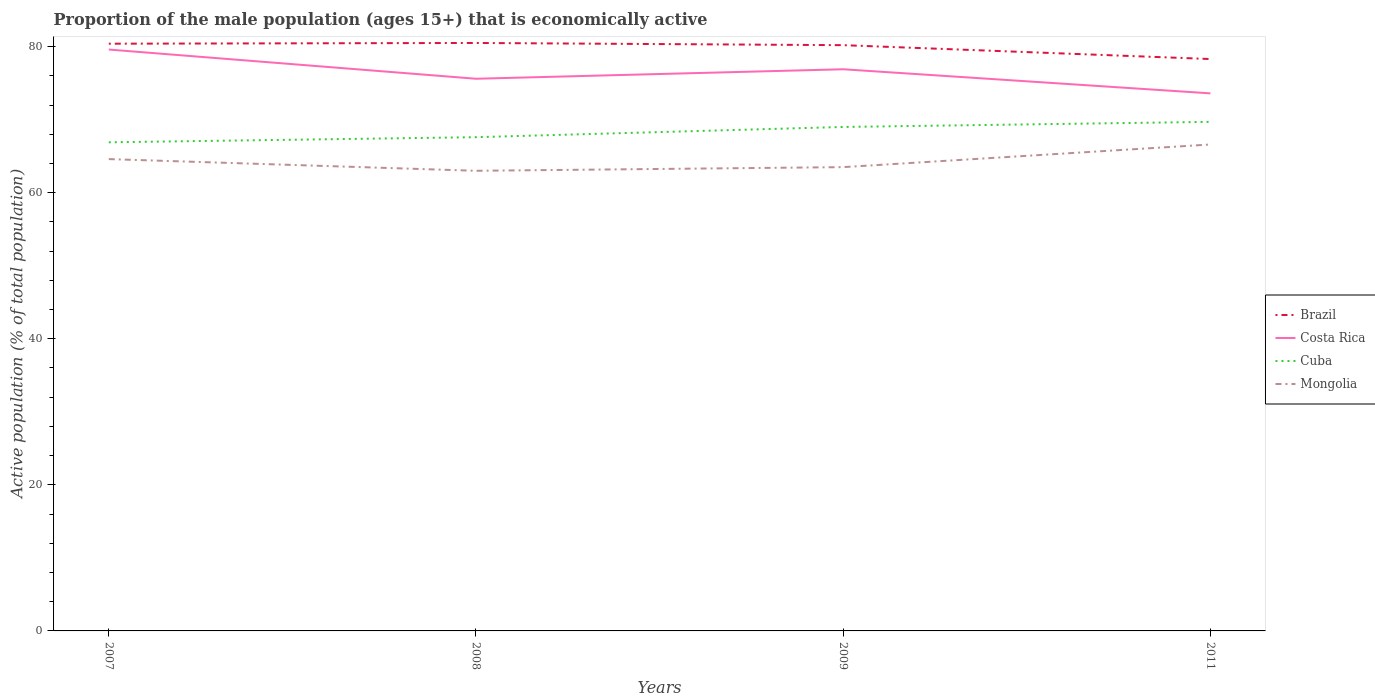Does the line corresponding to Brazil intersect with the line corresponding to Cuba?
Your answer should be very brief. No. Is the number of lines equal to the number of legend labels?
Provide a succinct answer. Yes. Across all years, what is the maximum proportion of the male population that is economically active in Brazil?
Offer a terse response. 78.3. In which year was the proportion of the male population that is economically active in Costa Rica maximum?
Keep it short and to the point. 2011. What is the total proportion of the male population that is economically active in Mongolia in the graph?
Provide a short and direct response. 1.1. What is the difference between the highest and the second highest proportion of the male population that is economically active in Brazil?
Keep it short and to the point. 2.2. What is the difference between the highest and the lowest proportion of the male population that is economically active in Cuba?
Give a very brief answer. 2. Are the values on the major ticks of Y-axis written in scientific E-notation?
Ensure brevity in your answer.  No. How many legend labels are there?
Provide a succinct answer. 4. How are the legend labels stacked?
Make the answer very short. Vertical. What is the title of the graph?
Your answer should be very brief. Proportion of the male population (ages 15+) that is economically active. Does "Luxembourg" appear as one of the legend labels in the graph?
Give a very brief answer. No. What is the label or title of the X-axis?
Your answer should be very brief. Years. What is the label or title of the Y-axis?
Offer a terse response. Active population (% of total population). What is the Active population (% of total population) of Brazil in 2007?
Give a very brief answer. 80.4. What is the Active population (% of total population) in Costa Rica in 2007?
Provide a short and direct response. 79.6. What is the Active population (% of total population) of Cuba in 2007?
Your answer should be compact. 66.9. What is the Active population (% of total population) of Mongolia in 2007?
Keep it short and to the point. 64.6. What is the Active population (% of total population) in Brazil in 2008?
Offer a terse response. 80.5. What is the Active population (% of total population) in Costa Rica in 2008?
Provide a short and direct response. 75.6. What is the Active population (% of total population) of Cuba in 2008?
Your response must be concise. 67.6. What is the Active population (% of total population) of Brazil in 2009?
Provide a succinct answer. 80.2. What is the Active population (% of total population) of Costa Rica in 2009?
Provide a succinct answer. 76.9. What is the Active population (% of total population) of Cuba in 2009?
Provide a short and direct response. 69. What is the Active population (% of total population) in Mongolia in 2009?
Offer a very short reply. 63.5. What is the Active population (% of total population) of Brazil in 2011?
Offer a very short reply. 78.3. What is the Active population (% of total population) of Costa Rica in 2011?
Make the answer very short. 73.6. What is the Active population (% of total population) of Cuba in 2011?
Offer a terse response. 69.7. What is the Active population (% of total population) in Mongolia in 2011?
Ensure brevity in your answer.  66.6. Across all years, what is the maximum Active population (% of total population) in Brazil?
Offer a terse response. 80.5. Across all years, what is the maximum Active population (% of total population) in Costa Rica?
Make the answer very short. 79.6. Across all years, what is the maximum Active population (% of total population) in Cuba?
Offer a very short reply. 69.7. Across all years, what is the maximum Active population (% of total population) in Mongolia?
Offer a terse response. 66.6. Across all years, what is the minimum Active population (% of total population) of Brazil?
Keep it short and to the point. 78.3. Across all years, what is the minimum Active population (% of total population) in Costa Rica?
Your answer should be very brief. 73.6. Across all years, what is the minimum Active population (% of total population) of Cuba?
Offer a very short reply. 66.9. What is the total Active population (% of total population) of Brazil in the graph?
Your response must be concise. 319.4. What is the total Active population (% of total population) in Costa Rica in the graph?
Ensure brevity in your answer.  305.7. What is the total Active population (% of total population) in Cuba in the graph?
Offer a very short reply. 273.2. What is the total Active population (% of total population) in Mongolia in the graph?
Your answer should be very brief. 257.7. What is the difference between the Active population (% of total population) of Brazil in 2007 and that in 2009?
Make the answer very short. 0.2. What is the difference between the Active population (% of total population) in Costa Rica in 2007 and that in 2009?
Provide a succinct answer. 2.7. What is the difference between the Active population (% of total population) of Mongolia in 2007 and that in 2009?
Offer a terse response. 1.1. What is the difference between the Active population (% of total population) of Mongolia in 2007 and that in 2011?
Make the answer very short. -2. What is the difference between the Active population (% of total population) in Cuba in 2008 and that in 2009?
Provide a short and direct response. -1.4. What is the difference between the Active population (% of total population) in Costa Rica in 2008 and that in 2011?
Give a very brief answer. 2. What is the difference between the Active population (% of total population) in Costa Rica in 2007 and the Active population (% of total population) in Mongolia in 2008?
Offer a terse response. 16.6. What is the difference between the Active population (% of total population) of Brazil in 2007 and the Active population (% of total population) of Costa Rica in 2009?
Ensure brevity in your answer.  3.5. What is the difference between the Active population (% of total population) of Brazil in 2007 and the Active population (% of total population) of Cuba in 2009?
Keep it short and to the point. 11.4. What is the difference between the Active population (% of total population) in Costa Rica in 2007 and the Active population (% of total population) in Cuba in 2009?
Provide a short and direct response. 10.6. What is the difference between the Active population (% of total population) of Costa Rica in 2007 and the Active population (% of total population) of Mongolia in 2009?
Your answer should be compact. 16.1. What is the difference between the Active population (% of total population) in Brazil in 2007 and the Active population (% of total population) in Mongolia in 2011?
Offer a terse response. 13.8. What is the difference between the Active population (% of total population) in Brazil in 2008 and the Active population (% of total population) in Costa Rica in 2009?
Offer a very short reply. 3.6. What is the difference between the Active population (% of total population) of Brazil in 2008 and the Active population (% of total population) of Cuba in 2009?
Ensure brevity in your answer.  11.5. What is the difference between the Active population (% of total population) of Brazil in 2008 and the Active population (% of total population) of Costa Rica in 2011?
Offer a terse response. 6.9. What is the difference between the Active population (% of total population) in Brazil in 2008 and the Active population (% of total population) in Mongolia in 2011?
Your response must be concise. 13.9. What is the difference between the Active population (% of total population) of Costa Rica in 2008 and the Active population (% of total population) of Mongolia in 2011?
Give a very brief answer. 9. What is the difference between the Active population (% of total population) of Cuba in 2008 and the Active population (% of total population) of Mongolia in 2011?
Offer a very short reply. 1. What is the difference between the Active population (% of total population) in Brazil in 2009 and the Active population (% of total population) in Cuba in 2011?
Ensure brevity in your answer.  10.5. What is the difference between the Active population (% of total population) in Brazil in 2009 and the Active population (% of total population) in Mongolia in 2011?
Provide a succinct answer. 13.6. What is the difference between the Active population (% of total population) of Costa Rica in 2009 and the Active population (% of total population) of Mongolia in 2011?
Keep it short and to the point. 10.3. What is the difference between the Active population (% of total population) in Cuba in 2009 and the Active population (% of total population) in Mongolia in 2011?
Ensure brevity in your answer.  2.4. What is the average Active population (% of total population) of Brazil per year?
Provide a succinct answer. 79.85. What is the average Active population (% of total population) in Costa Rica per year?
Your answer should be compact. 76.42. What is the average Active population (% of total population) of Cuba per year?
Give a very brief answer. 68.3. What is the average Active population (% of total population) in Mongolia per year?
Ensure brevity in your answer.  64.42. In the year 2007, what is the difference between the Active population (% of total population) in Brazil and Active population (% of total population) in Costa Rica?
Your response must be concise. 0.8. In the year 2007, what is the difference between the Active population (% of total population) in Brazil and Active population (% of total population) in Cuba?
Offer a very short reply. 13.5. In the year 2007, what is the difference between the Active population (% of total population) of Cuba and Active population (% of total population) of Mongolia?
Your answer should be very brief. 2.3. In the year 2008, what is the difference between the Active population (% of total population) of Cuba and Active population (% of total population) of Mongolia?
Give a very brief answer. 4.6. In the year 2009, what is the difference between the Active population (% of total population) of Brazil and Active population (% of total population) of Mongolia?
Give a very brief answer. 16.7. In the year 2009, what is the difference between the Active population (% of total population) of Cuba and Active population (% of total population) of Mongolia?
Offer a very short reply. 5.5. In the year 2011, what is the difference between the Active population (% of total population) in Brazil and Active population (% of total population) in Costa Rica?
Provide a short and direct response. 4.7. In the year 2011, what is the difference between the Active population (% of total population) of Brazil and Active population (% of total population) of Cuba?
Your response must be concise. 8.6. In the year 2011, what is the difference between the Active population (% of total population) of Brazil and Active population (% of total population) of Mongolia?
Offer a very short reply. 11.7. In the year 2011, what is the difference between the Active population (% of total population) in Cuba and Active population (% of total population) in Mongolia?
Offer a terse response. 3.1. What is the ratio of the Active population (% of total population) of Brazil in 2007 to that in 2008?
Make the answer very short. 1. What is the ratio of the Active population (% of total population) of Costa Rica in 2007 to that in 2008?
Keep it short and to the point. 1.05. What is the ratio of the Active population (% of total population) in Mongolia in 2007 to that in 2008?
Make the answer very short. 1.03. What is the ratio of the Active population (% of total population) of Costa Rica in 2007 to that in 2009?
Your answer should be compact. 1.04. What is the ratio of the Active population (% of total population) of Cuba in 2007 to that in 2009?
Provide a short and direct response. 0.97. What is the ratio of the Active population (% of total population) in Mongolia in 2007 to that in 2009?
Your answer should be very brief. 1.02. What is the ratio of the Active population (% of total population) in Brazil in 2007 to that in 2011?
Offer a terse response. 1.03. What is the ratio of the Active population (% of total population) of Costa Rica in 2007 to that in 2011?
Offer a very short reply. 1.08. What is the ratio of the Active population (% of total population) of Cuba in 2007 to that in 2011?
Provide a succinct answer. 0.96. What is the ratio of the Active population (% of total population) in Mongolia in 2007 to that in 2011?
Make the answer very short. 0.97. What is the ratio of the Active population (% of total population) in Costa Rica in 2008 to that in 2009?
Offer a terse response. 0.98. What is the ratio of the Active population (% of total population) in Cuba in 2008 to that in 2009?
Make the answer very short. 0.98. What is the ratio of the Active population (% of total population) of Brazil in 2008 to that in 2011?
Offer a very short reply. 1.03. What is the ratio of the Active population (% of total population) in Costa Rica in 2008 to that in 2011?
Your answer should be compact. 1.03. What is the ratio of the Active population (% of total population) of Cuba in 2008 to that in 2011?
Offer a terse response. 0.97. What is the ratio of the Active population (% of total population) in Mongolia in 2008 to that in 2011?
Keep it short and to the point. 0.95. What is the ratio of the Active population (% of total population) of Brazil in 2009 to that in 2011?
Provide a short and direct response. 1.02. What is the ratio of the Active population (% of total population) in Costa Rica in 2009 to that in 2011?
Offer a very short reply. 1.04. What is the ratio of the Active population (% of total population) of Cuba in 2009 to that in 2011?
Make the answer very short. 0.99. What is the ratio of the Active population (% of total population) of Mongolia in 2009 to that in 2011?
Your answer should be compact. 0.95. What is the difference between the highest and the second highest Active population (% of total population) in Brazil?
Your answer should be very brief. 0.1. What is the difference between the highest and the second highest Active population (% of total population) in Mongolia?
Ensure brevity in your answer.  2. What is the difference between the highest and the lowest Active population (% of total population) in Costa Rica?
Offer a terse response. 6. What is the difference between the highest and the lowest Active population (% of total population) of Cuba?
Offer a very short reply. 2.8. What is the difference between the highest and the lowest Active population (% of total population) of Mongolia?
Offer a very short reply. 3.6. 